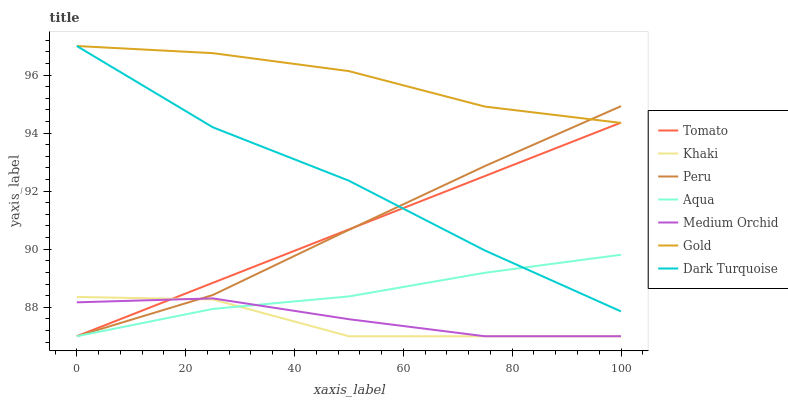Does Khaki have the minimum area under the curve?
Answer yes or no. Yes. Does Gold have the maximum area under the curve?
Answer yes or no. Yes. Does Gold have the minimum area under the curve?
Answer yes or no. No. Does Khaki have the maximum area under the curve?
Answer yes or no. No. Is Tomato the smoothest?
Answer yes or no. Yes. Is Khaki the roughest?
Answer yes or no. Yes. Is Gold the smoothest?
Answer yes or no. No. Is Gold the roughest?
Answer yes or no. No. Does Gold have the lowest value?
Answer yes or no. No. Does Dark Turquoise have the highest value?
Answer yes or no. Yes. Does Khaki have the highest value?
Answer yes or no. No. Is Medium Orchid less than Dark Turquoise?
Answer yes or no. Yes. Is Dark Turquoise greater than Khaki?
Answer yes or no. Yes. Does Tomato intersect Medium Orchid?
Answer yes or no. Yes. Is Tomato less than Medium Orchid?
Answer yes or no. No. Is Tomato greater than Medium Orchid?
Answer yes or no. No. Does Medium Orchid intersect Dark Turquoise?
Answer yes or no. No. 